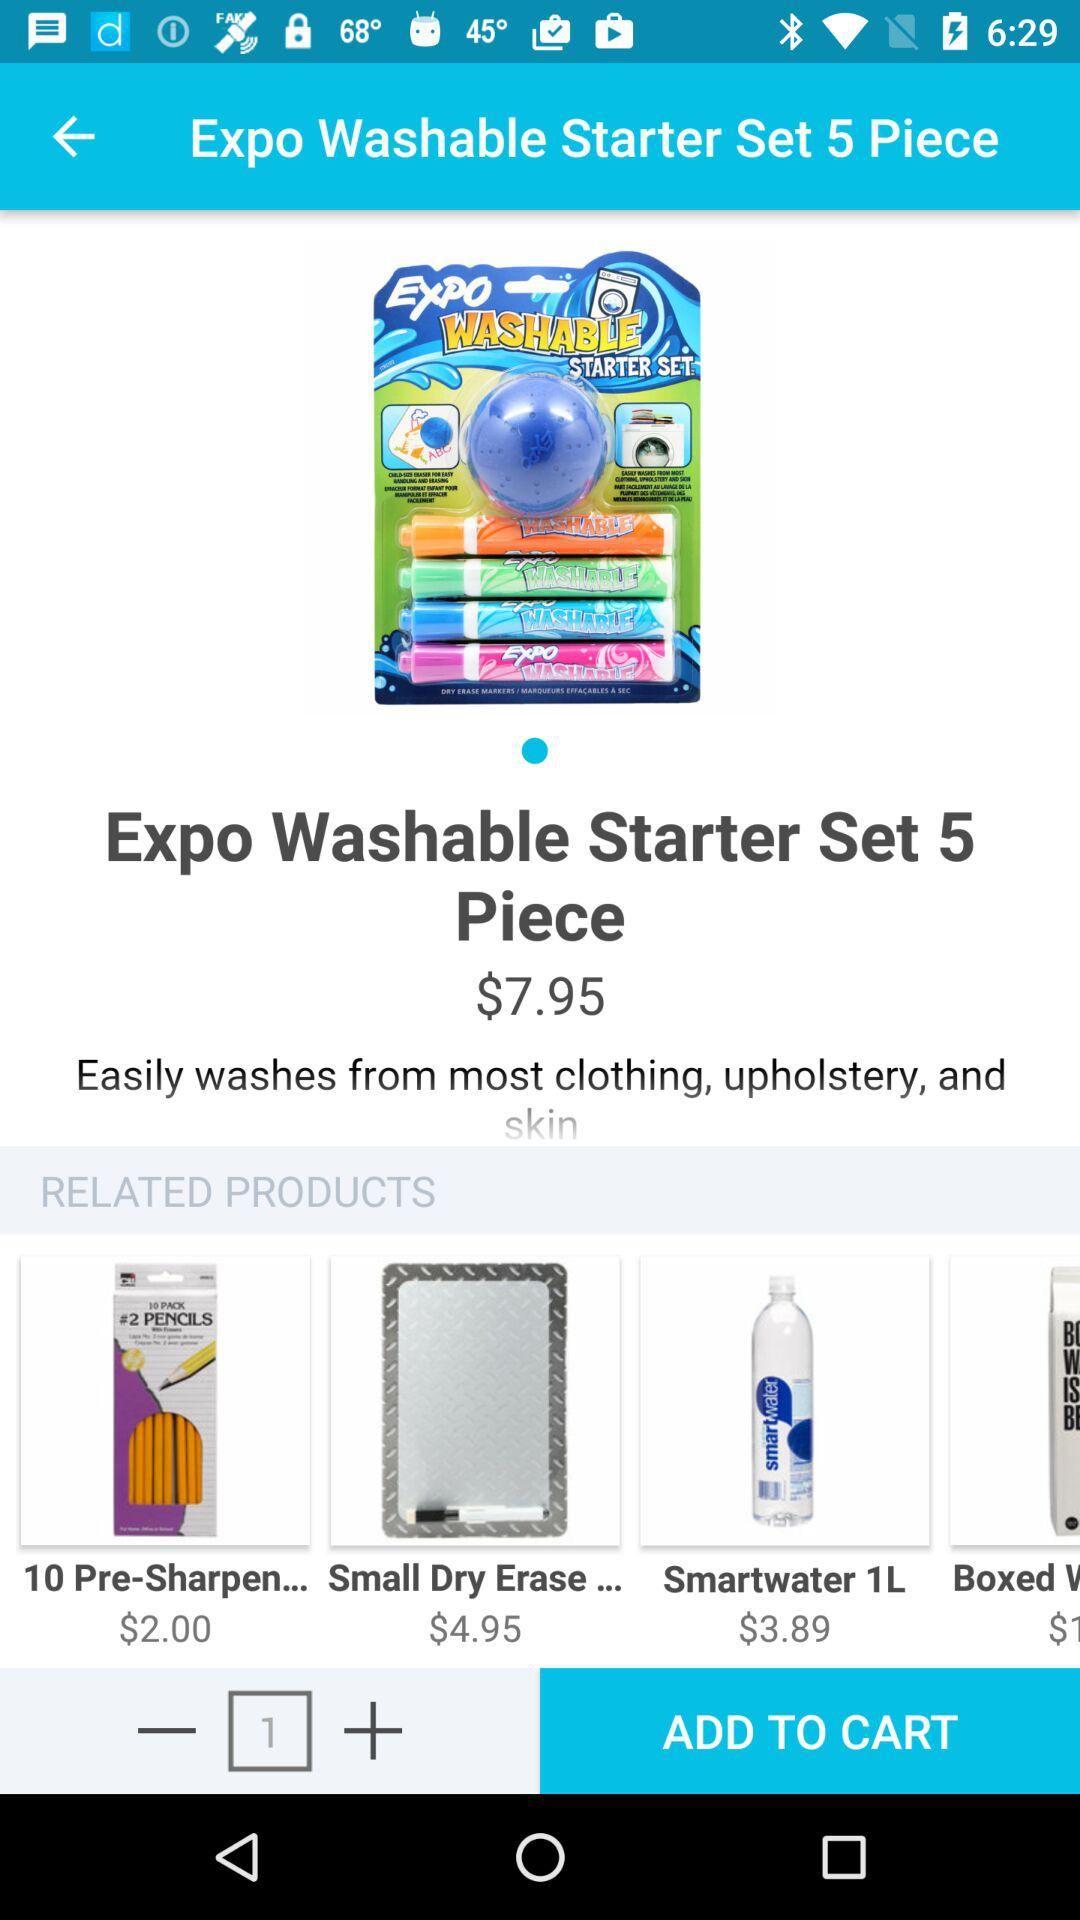Which item has a price of $2.00? The item that has a price of $2.00 is "10 Pre-Sharpen...". 